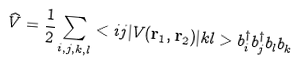<formula> <loc_0><loc_0><loc_500><loc_500>\widehat { V } = \frac { 1 } { 2 } \sum _ { i , j , k , l } < i j | V ( { \mathbf r _ { 1 } , \mathbf r _ { 2 } } ) | k l > b _ { i } ^ { \dagger } b _ { j } ^ { \dagger } b _ { l } b _ { k }</formula> 